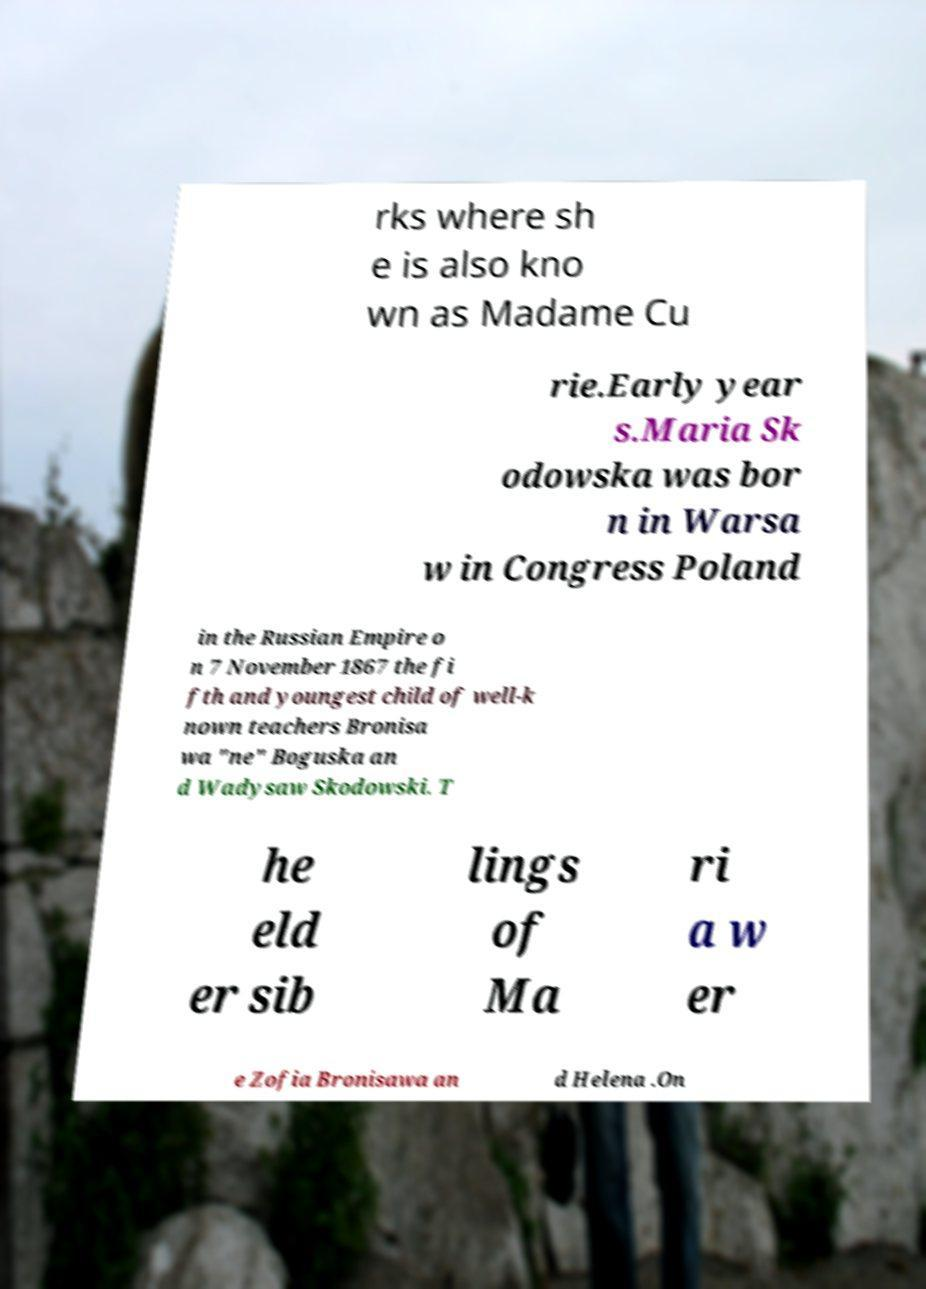Could you extract and type out the text from this image? rks where sh e is also kno wn as Madame Cu rie.Early year s.Maria Sk odowska was bor n in Warsa w in Congress Poland in the Russian Empire o n 7 November 1867 the fi fth and youngest child of well-k nown teachers Bronisa wa "ne" Boguska an d Wadysaw Skodowski. T he eld er sib lings of Ma ri a w er e Zofia Bronisawa an d Helena .On 